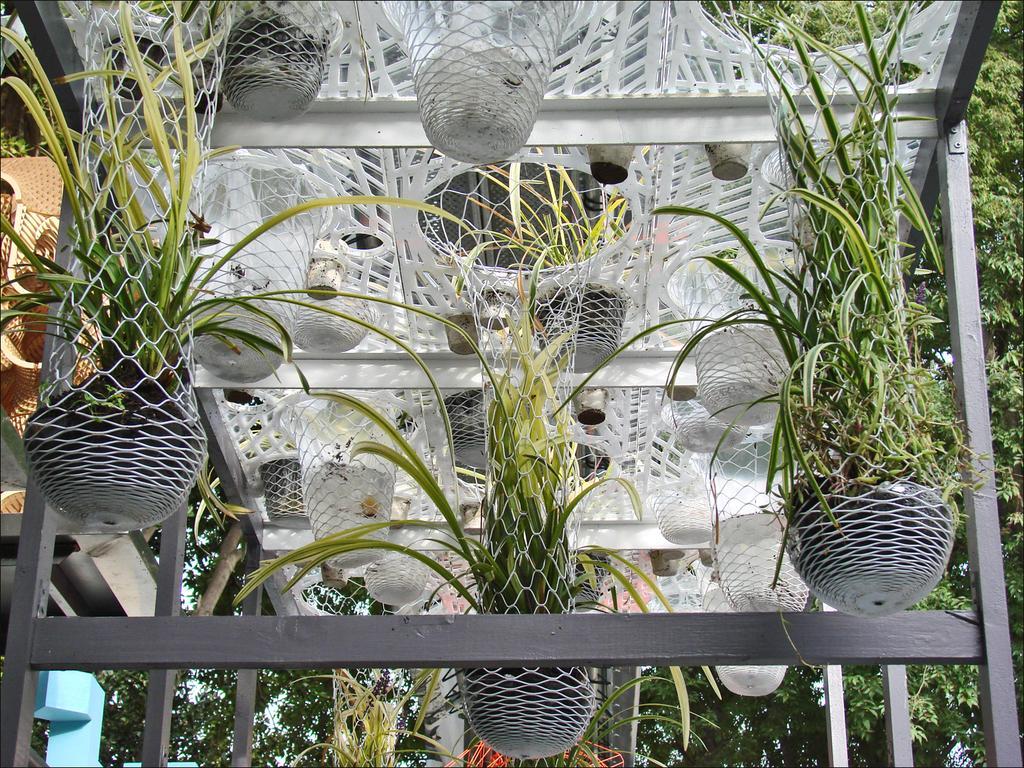How would you summarize this image in a sentence or two? In this image in the center there is a roof and there are some flower pots, net and plants. And in the background there are some trees and objects. 